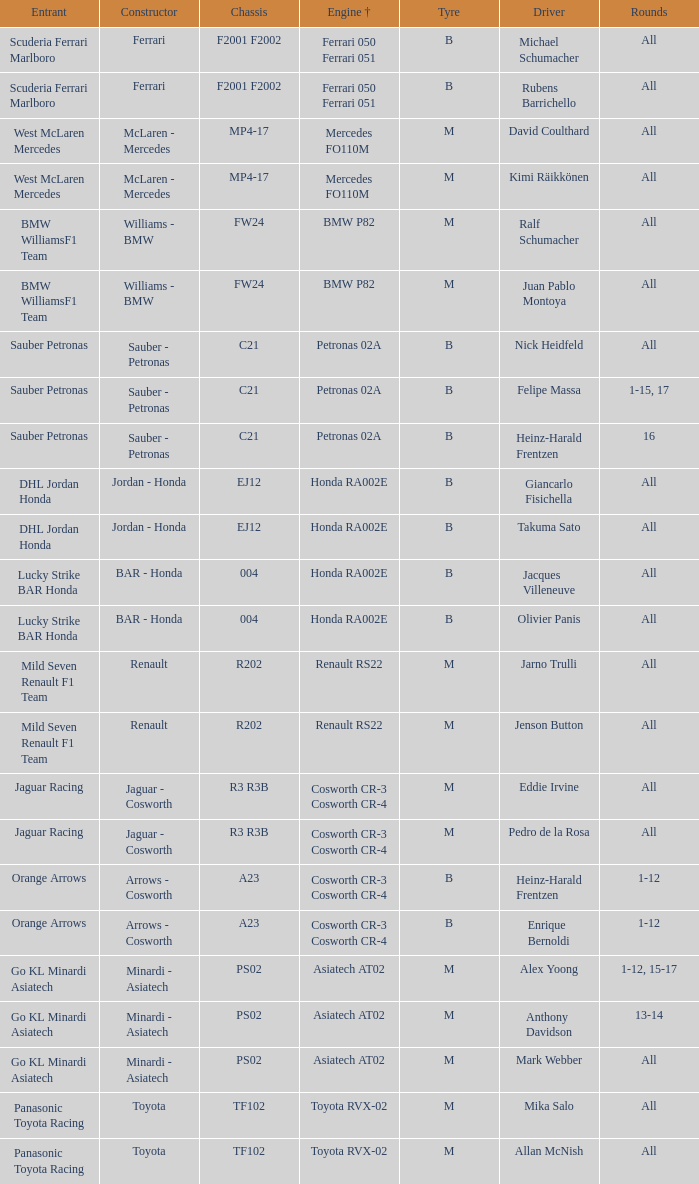In a scenario where all rounds are done, the tire is m, and david coulthard is the driver, what is the engine? Mercedes FO110M. 